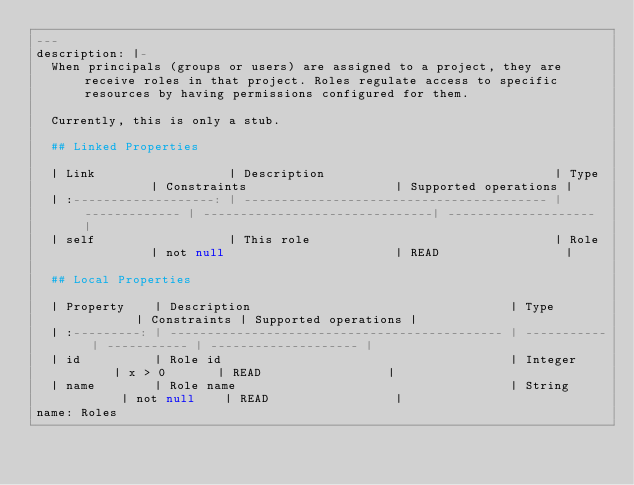<code> <loc_0><loc_0><loc_500><loc_500><_YAML_>---
description: |-
  When principals (groups or users) are assigned to a project, they are receive roles in that project. Roles regulate access to specific resources by having permissions configured for them.

  Currently, this is only a stub.

  ## Linked Properties

  | Link                  | Description                               | Type          | Constraints                    | Supported operations |
  | :-------------------: | ----------------------------------------- | ------------- | -------------------------------| -------------------- |
  | self                  | This role                                 | Role          | not null                       | READ                 |

  ## Local Properties

  | Property    | Description                                   | Type        | Constraints | Supported operations |
  | :---------: | --------------------------------------------- | ----------- | ----------- | -------------------- |
  | id          | Role id                                       | Integer     | x > 0       | READ                 |
  | name        | Role name                                     | String      | not null    | READ                 |
name: Roles
</code> 